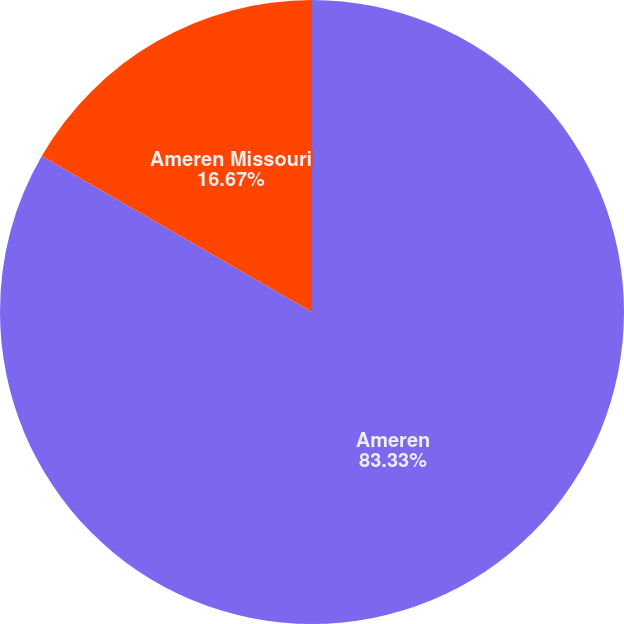Convert chart to OTSL. <chart><loc_0><loc_0><loc_500><loc_500><pie_chart><fcel>Ameren<fcel>Ameren Missouri<nl><fcel>83.33%<fcel>16.67%<nl></chart> 